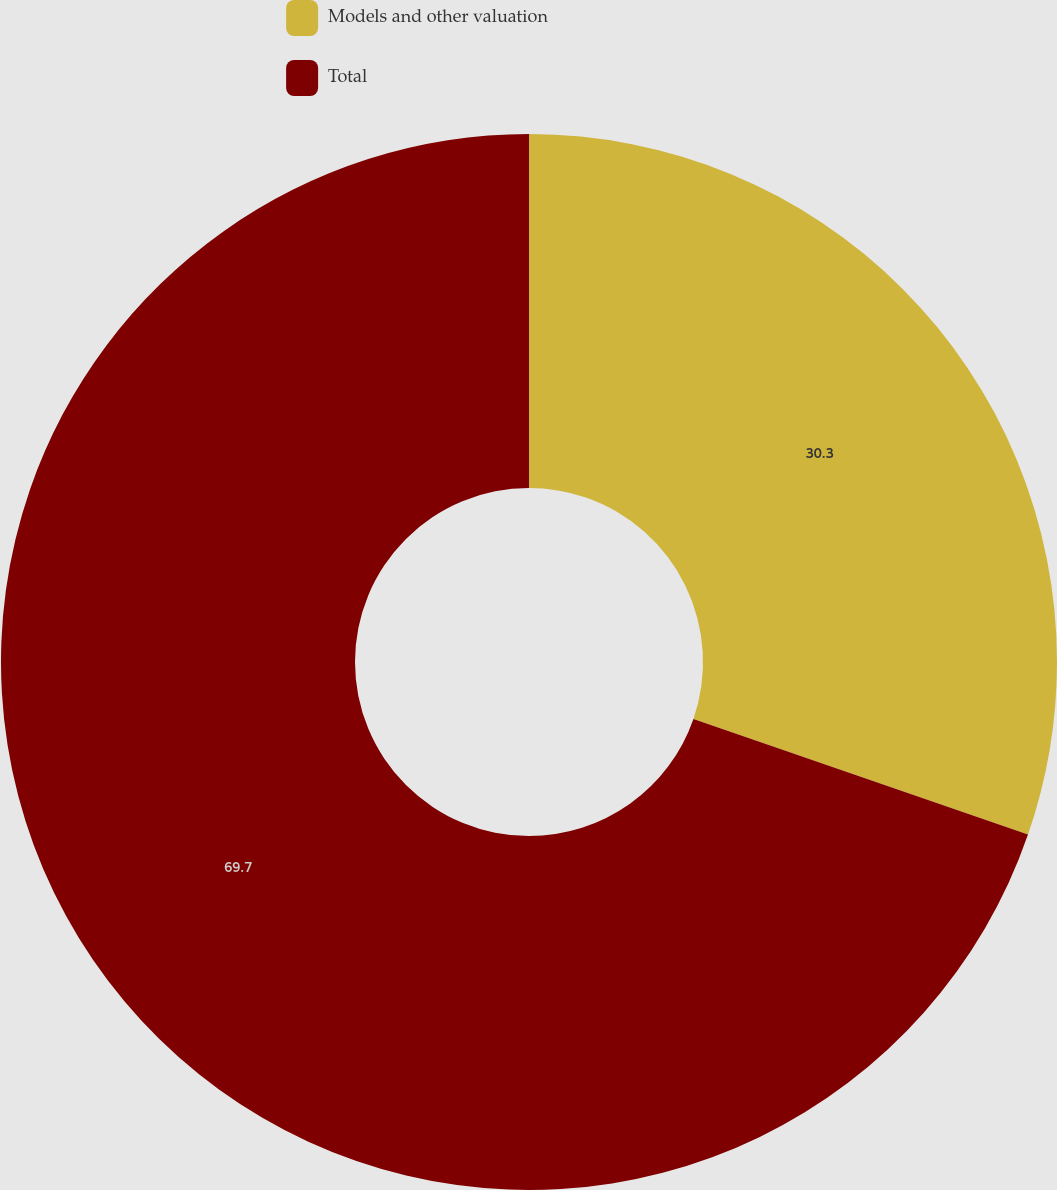Convert chart. <chart><loc_0><loc_0><loc_500><loc_500><pie_chart><fcel>Models and other valuation<fcel>Total<nl><fcel>30.3%<fcel>69.7%<nl></chart> 